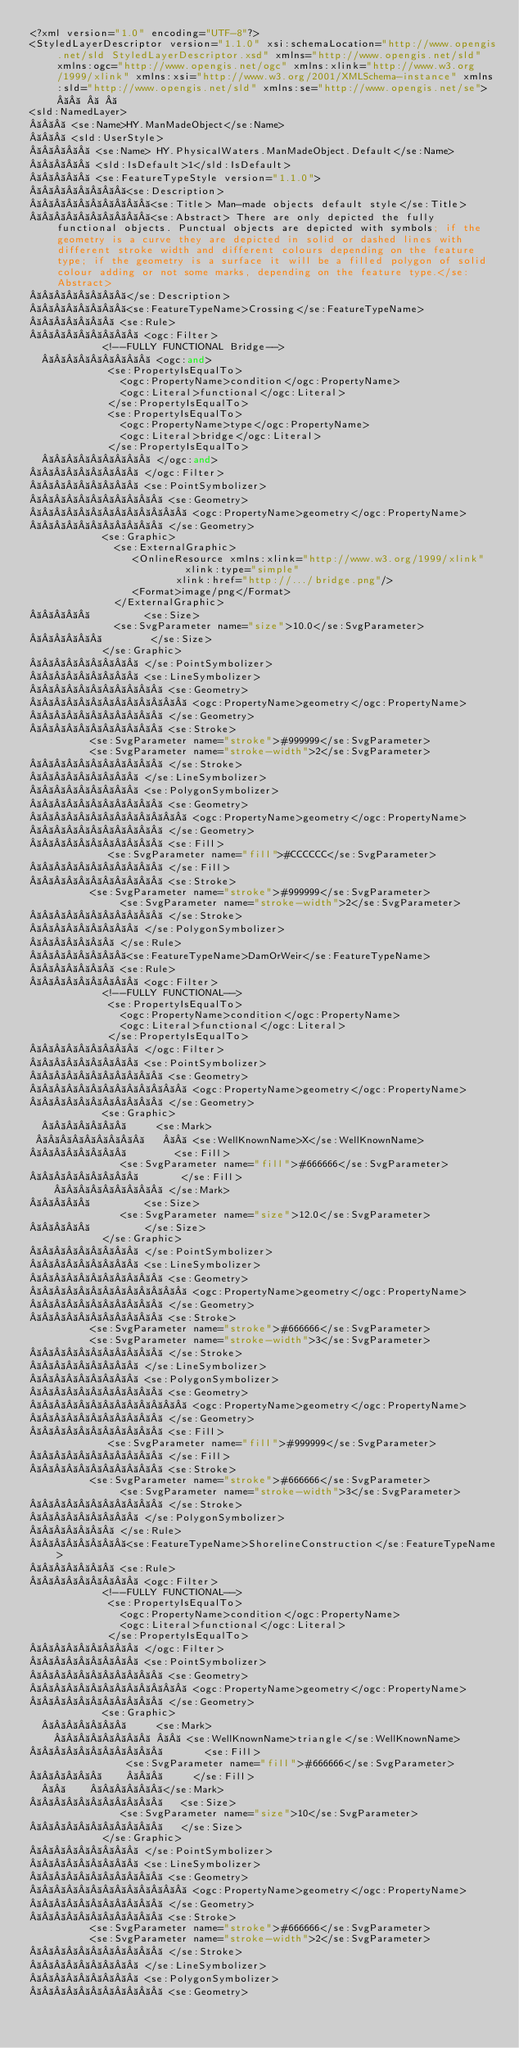<code> <loc_0><loc_0><loc_500><loc_500><_Scheme_><?xml version="1.0" encoding="UTF-8"?>
<StyledLayerDescriptor version="1.1.0" xsi:schemaLocation="http://www.opengis.net/sld StyledLayerDescriptor.xsd" xmlns="http://www.opengis.net/sld" xmlns:ogc="http://www.opengis.net/ogc" xmlns:xlink="http://www.w3.org/1999/xlink" xmlns:xsi="http://www.w3.org/2001/XMLSchema-instance" xmlns:sld="http://www.opengis.net/sld" xmlns:se="http://www.opengis.net/se">       
<sld:NamedLayer>
    <se:Name>HY.ManMadeObject</se:Name>
    <sld:UserStyle>
      <se:Name> HY.PhysicalWaters.ManMadeObject.Default</se:Name>
      <sld:IsDefault>1</sld:IsDefault>
      <se:FeatureTypeStyle version="1.1.0">
        <se:Description>
          <se:Title> Man-made objects default style</se:Title>
          <se:Abstract> There are only depicted the fully functional objects. Punctual objects are depicted with symbols; if the geometry is a curve they are depicted in solid or dashed lines with different stroke width and different colours depending on the feature type; if the geometry is a surface it will be a filled polygon of solid colour adding or not some marks, depending on the feature type.</se:Abstract>
        </se:Description>
        <se:FeatureTypeName>Crossing</se:FeatureTypeName>
        <se:Rule>
          <ogc:Filter>
            <!--FULLY FUNCTIONAL Bridge-->
            <ogc:and>
             <se:PropertyIsEqualTo>
               <ogc:PropertyName>condition</ogc:PropertyName>
               <ogc:Literal>functional</ogc:Literal>
             </se:PropertyIsEqualTo>
             <se:PropertyIsEqualTo>
               <ogc:PropertyName>type</ogc:PropertyName>
               <ogc:Literal>bridge</ogc:Literal>
             </se:PropertyIsEqualTo>
            </ogc:and>
          </ogc:Filter>
          <se:PointSymbolizer>
            <se:Geometry>
              <ogc:PropertyName>geometry</ogc:PropertyName>
            </se:Geometry>
            <se:Graphic>
              <se:ExternalGraphic>
                 <OnlineResource xmlns:xlink="http://www.w3.org/1999/xlink"     xlink:type="simple" 
                        xlink:href="http://.../bridge.png"/>
                 <Format>image/png</Format> 
              </ExternalGraphic> 
              <se:Size>
		          <se:SvgParameter name="size">10.0</se:SvgParameter>
              </se:Size>
            </se:Graphic>
          </se:PointSymbolizer>
          <se:LineSymbolizer>
            <se:Geometry>
              <ogc:PropertyName>geometry</ogc:PropertyName>
            </se:Geometry>
            <se:Stroke>
					<se:SvgParameter name="stroke">#999999</se:SvgParameter>
					<se:SvgParameter name="stroke-width">2</se:SvgParameter>
            </se:Stroke>
          </se:LineSymbolizer>
          <se:PolygonSymbolizer>
            <se:Geometry>
              <ogc:PropertyName>geometry</ogc:PropertyName>
            </se:Geometry>
            <se:Fill>
				     <se:SvgParameter name="fill">#CCCCCC</se:SvgParameter>
            </se:Fill>
            <se:Stroke>
					<se:SvgParameter name="stroke">#999999</se:SvgParameter>
               <se:SvgParameter name="stroke-width">2</se:SvgParameter>
            </se:Stroke>
          </se:PolygonSymbolizer>
        </se:Rule>
        <se:FeatureTypeName>DamOrWeir</se:FeatureTypeName>
        <se:Rule>
          <ogc:Filter>
            <!--FULLY FUNCTIONAL-->
             <se:PropertyIsEqualTo>
               <ogc:PropertyName>condition</ogc:PropertyName>
               <ogc:Literal>functional</ogc:Literal>
             </se:PropertyIsEqualTo>
          </ogc:Filter>
          <se:PointSymbolizer>
            <se:Geometry>
              <ogc:PropertyName>geometry</ogc:PropertyName>
            </se:Geometry>
            <se:Graphic>
              <se:Mark>
                <se:WellKnownName>X</se:WellKnownName>
                <se:Fill>
			         <se:SvgParameter name="fill">#666666</se:SvgParameter>
                </se:Fill>           
              </se:Mark>
              <se:Size>
	             <se:SvgParameter name="size">12.0</se:SvgParameter>
              </se:Size>
            </se:Graphic>
          </se:PointSymbolizer>
          <se:LineSymbolizer>
            <se:Geometry>
              <ogc:PropertyName>geometry</ogc:PropertyName>
            </se:Geometry>
            <se:Stroke>
					<se:SvgParameter name="stroke">#666666</se:SvgParameter>
					<se:SvgParameter name="stroke-width">3</se:SvgParameter>
            </se:Stroke>
          </se:LineSymbolizer>
          <se:PolygonSymbolizer>
            <se:Geometry>
              <ogc:PropertyName>geometry</ogc:PropertyName>
            </se:Geometry>
            <se:Fill>
				     <se:SvgParameter name="fill">#999999</se:SvgParameter>
            </se:Fill>
            <se:Stroke>
					<se:SvgParameter name="stroke">#666666</se:SvgParameter>
               <se:SvgParameter name="stroke-width">3</se:SvgParameter>
            </se:Stroke>
          </se:PolygonSymbolizer>
        </se:Rule>
        <se:FeatureTypeName>ShorelineConstruction</se:FeatureTypeName>
        <se:Rule>
          <ogc:Filter>
            <!--FULLY FUNCTIONAL-->
             <se:PropertyIsEqualTo>
               <ogc:PropertyName>condition</ogc:PropertyName>
               <ogc:Literal>functional</ogc:Literal>
             </se:PropertyIsEqualTo>
          </ogc:Filter>
          <se:PointSymbolizer>
            <se:Geometry>
              <ogc:PropertyName>geometry</ogc:PropertyName>
            </se:Geometry>
            <se:Graphic>
              <se:Mark>
                <se:WellKnownName>triangle</se:WellKnownName>
                  <se:Fill>
      			    <se:SvgParameter name="fill">#666666</se:SvgParameter>
                  </se:Fill>
              </se:Mark>
              <se:Size>
			         <se:SvgParameter name="size">10</se:SvgParameter>
              </se:Size>
            </se:Graphic>
          </se:PointSymbolizer>
          <se:LineSymbolizer>
            <se:Geometry>
              <ogc:PropertyName>geometry</ogc:PropertyName>
            </se:Geometry>
            <se:Stroke>
					<se:SvgParameter name="stroke">#666666</se:SvgParameter>
					<se:SvgParameter name="stroke-width">2</se:SvgParameter>
            </se:Stroke>
          </se:LineSymbolizer>
          <se:PolygonSymbolizer>
            <se:Geometry></code> 